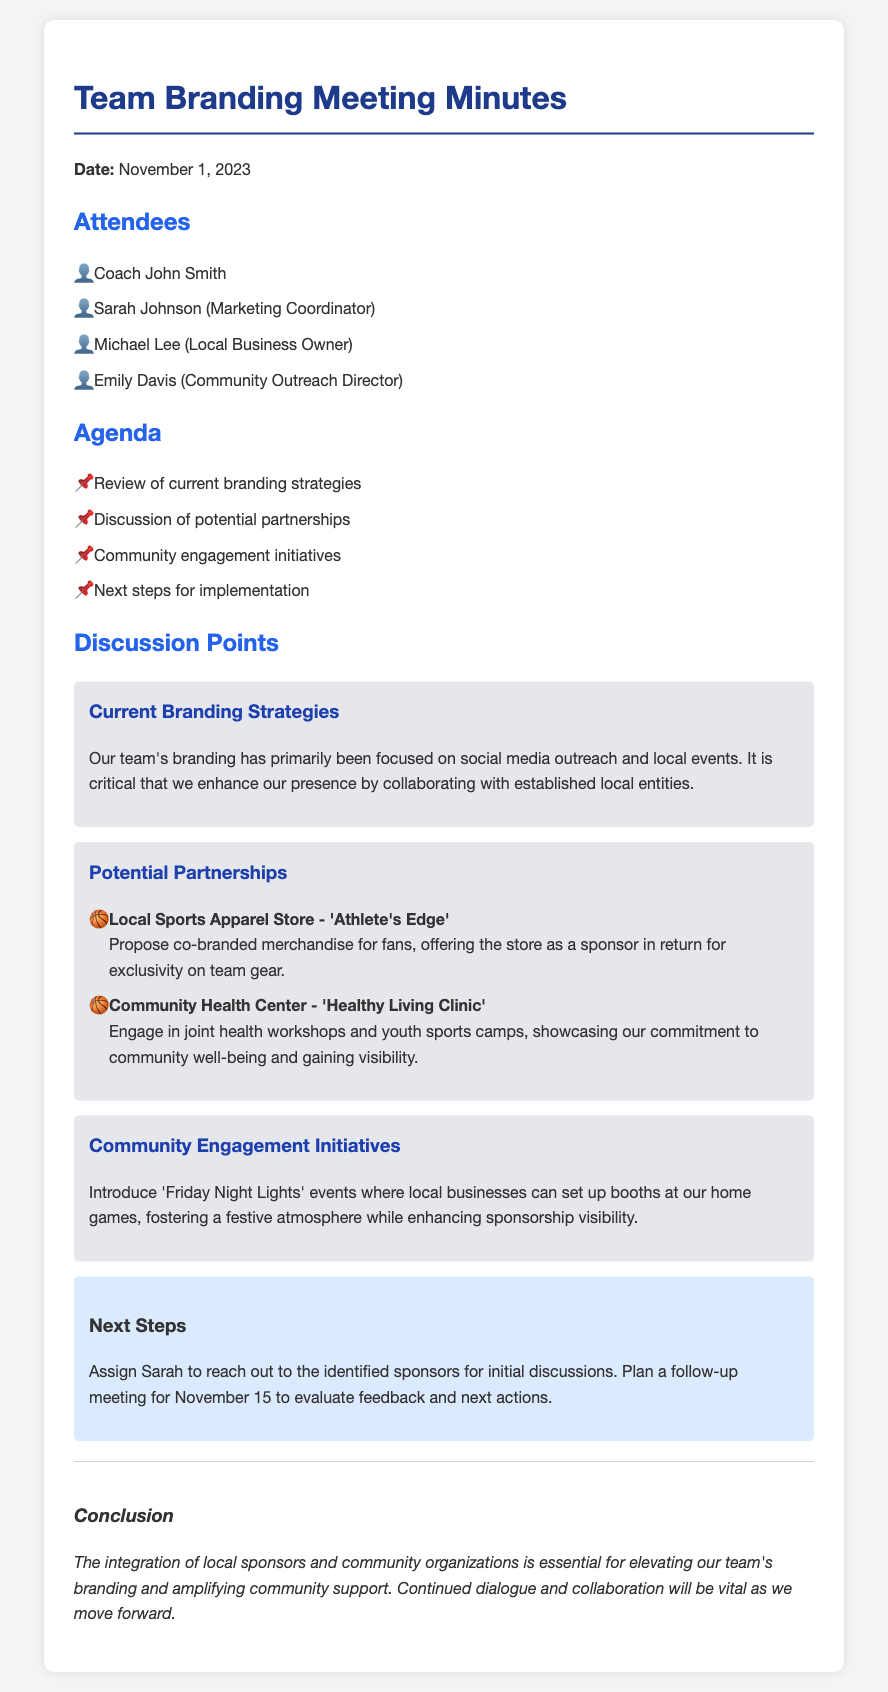What is the date of the meeting? The date of the meeting is specified at the beginning of the document, which is November 1, 2023.
Answer: November 1, 2023 Who is the Marketing Coordinator? The attendees section lists Sarah Johnson as the Marketing Coordinator.
Answer: Sarah Johnson What is the first agenda item? The agenda lists the first item as the review of current branding strategies.
Answer: Review of current branding strategies What local store is proposed for a partnership? The document mentions the local sports apparel store 'Athlete's Edge' for a potential partnership.
Answer: Athlete's Edge How many community engagement initiatives are discussed? The document outlines one main community engagement initiative, which is 'Friday Night Lights' events.
Answer: One What is the next step after the meeting? The next step specified is to assign Sarah to reach out to the identified sponsors for initial discussions.
Answer: Assign Sarah to reach out What will happen at the follow-up meeting? The follow-up meeting planned for November 15 is to evaluate feedback and next actions.
Answer: Evaluate feedback and next actions What is the conclusion about integrating local sponsors? The conclusion emphasizes that the integration of local sponsors and community organizations is essential for the team's branding.
Answer: Essential for branding 